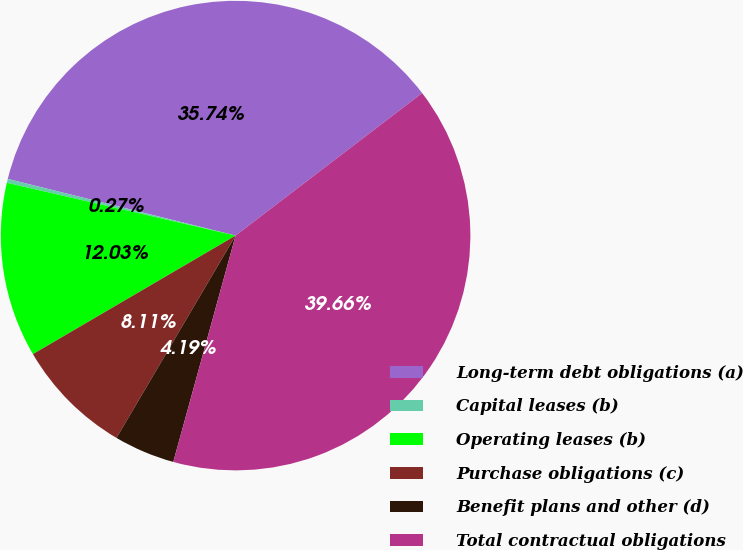Convert chart. <chart><loc_0><loc_0><loc_500><loc_500><pie_chart><fcel>Long-term debt obligations (a)<fcel>Capital leases (b)<fcel>Operating leases (b)<fcel>Purchase obligations (c)<fcel>Benefit plans and other (d)<fcel>Total contractual obligations<nl><fcel>35.73%<fcel>0.27%<fcel>12.03%<fcel>8.11%<fcel>4.19%<fcel>39.65%<nl></chart> 